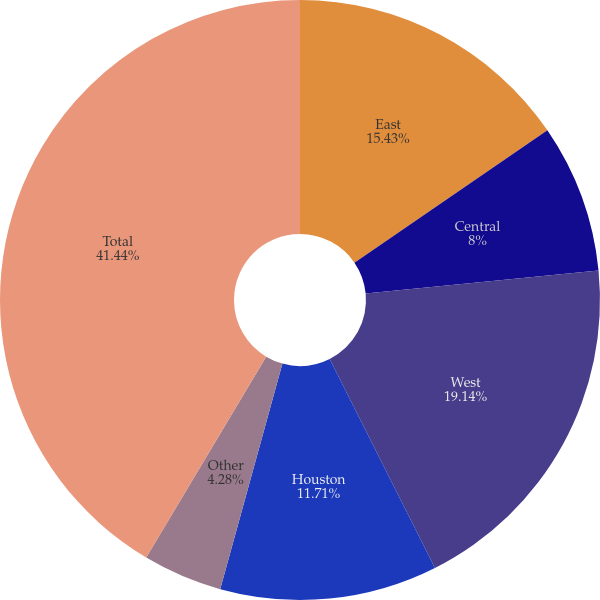Convert chart to OTSL. <chart><loc_0><loc_0><loc_500><loc_500><pie_chart><fcel>East<fcel>Central<fcel>West<fcel>Houston<fcel>Other<fcel>Total<nl><fcel>15.43%<fcel>8.0%<fcel>19.14%<fcel>11.71%<fcel>4.28%<fcel>41.43%<nl></chart> 